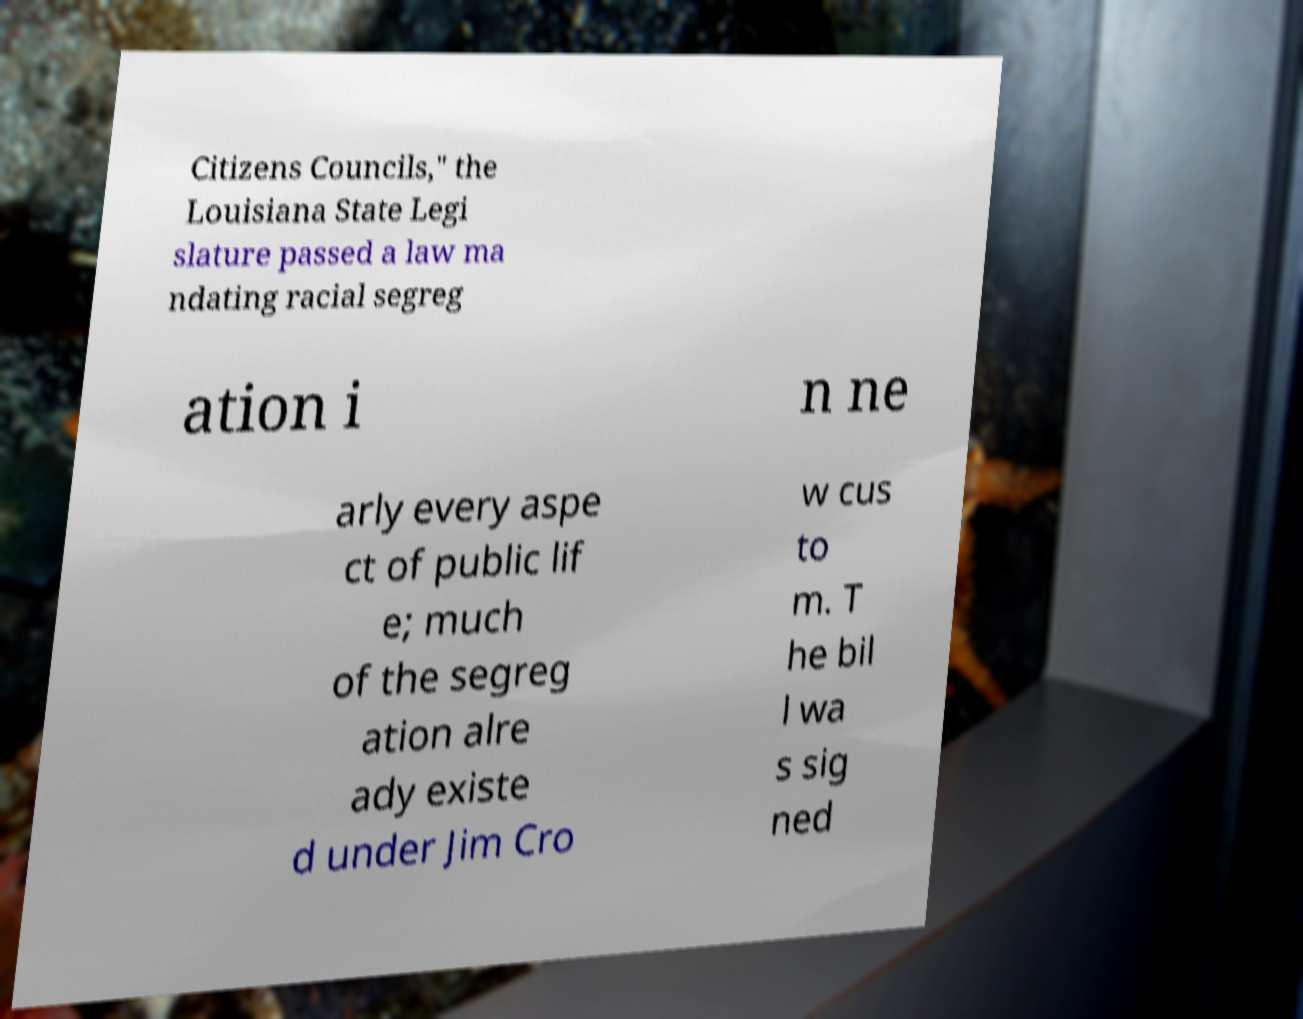Please identify and transcribe the text found in this image. Citizens Councils," the Louisiana State Legi slature passed a law ma ndating racial segreg ation i n ne arly every aspe ct of public lif e; much of the segreg ation alre ady existe d under Jim Cro w cus to m. T he bil l wa s sig ned 